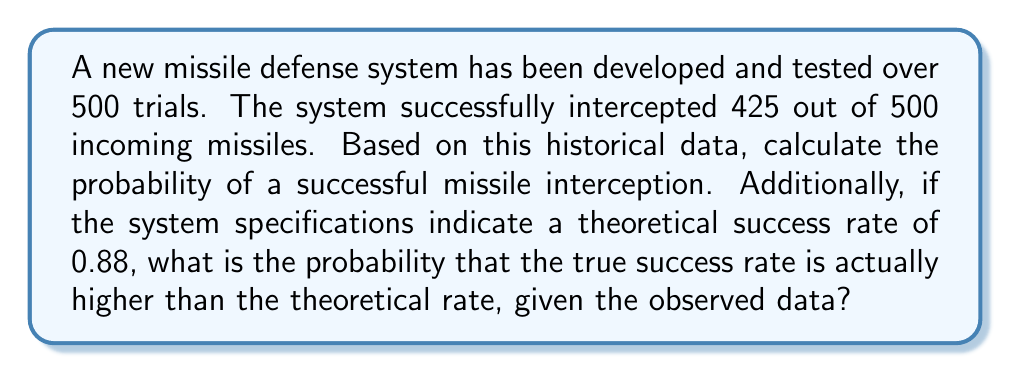Show me your answer to this math problem. To solve this problem, we'll use concepts from probability theory and statistical inference.

1. Calculating the probability of successful interception based on historical data:
   The probability is simply the number of successful interceptions divided by the total number of trials.

   $P(\text{success}) = \frac{\text{number of successes}}{\text{total number of trials}} = \frac{425}{500} = 0.85$

2. Determining if the true success rate is higher than the theoretical rate:
   We'll use a normal approximation to the binomial distribution, which is appropriate given the large sample size.

   Let $p$ be the true probability of success, and $\hat{p}$ be the observed probability.
   
   $\hat{p} = 0.85$
   Theoretical $p_0 = 0.88$
   
   Under the null hypothesis $H_0: p = p_0 = 0.88$
   
   The standard error of $\hat{p}$ is:
   
   $SE(\hat{p}) = \sqrt{\frac{p_0(1-p_0)}{n}} = \sqrt{\frac{0.88(1-0.88)}{500}} = 0.0145$

   The z-score is:
   
   $z = \frac{\hat{p} - p_0}{SE(\hat{p})} = \frac{0.85 - 0.88}{0.0145} = -2.069$

   The probability that the true success rate is higher than 0.88 is equivalent to the probability of observing a z-score less than or equal to -2.069 under the standard normal distribution, given that the true probability is 0.88.

   $P(Z \leq -2.069) = 1 - P(Z \leq 2.069) = 1 - 0.9808 = 0.0192$

   Therefore, the probability that the true success rate is higher than 0.88 is 0.0192 or approximately 1.92%.
Answer: The probability of a successful missile interception based on historical data is 0.85.
The probability that the true success rate is higher than the theoretical rate of 0.88, given the observed data, is approximately 0.0192 or 1.92%. 